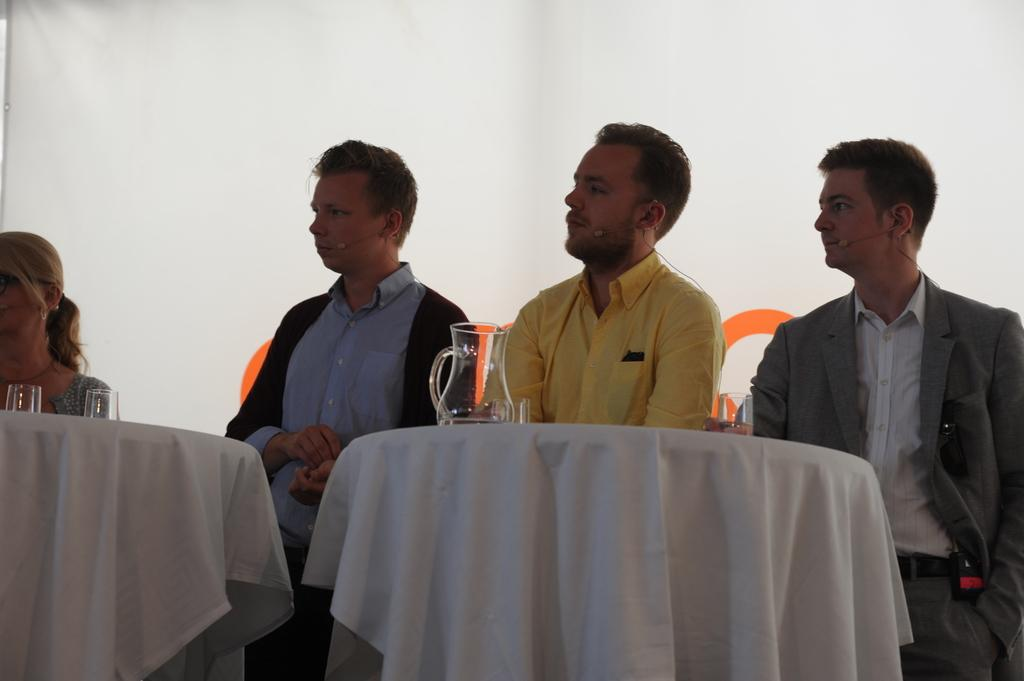What is present in the image that can be used for covering or cleaning? There is a cloth in the image that can be used for covering or cleaning. What are the people in the image doing? The people in the image are sitting on chairs. What is the main piece of furniture in the image? There is a table in the image. What can be seen on the table in the image? There are glasses on the table in the image. How many dolls are sitting on the carriage in the image? There is no carriage or dolls present in the image. What type of vase is placed on the table in the image? There is no vase present in the image; only glasses are visible on the table. 